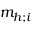<formula> <loc_0><loc_0><loc_500><loc_500>m _ { h ; i }</formula> 